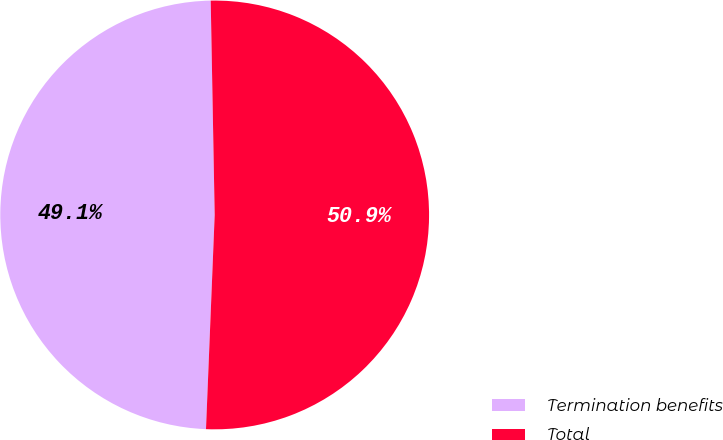<chart> <loc_0><loc_0><loc_500><loc_500><pie_chart><fcel>Termination benefits<fcel>Total<nl><fcel>49.06%<fcel>50.94%<nl></chart> 